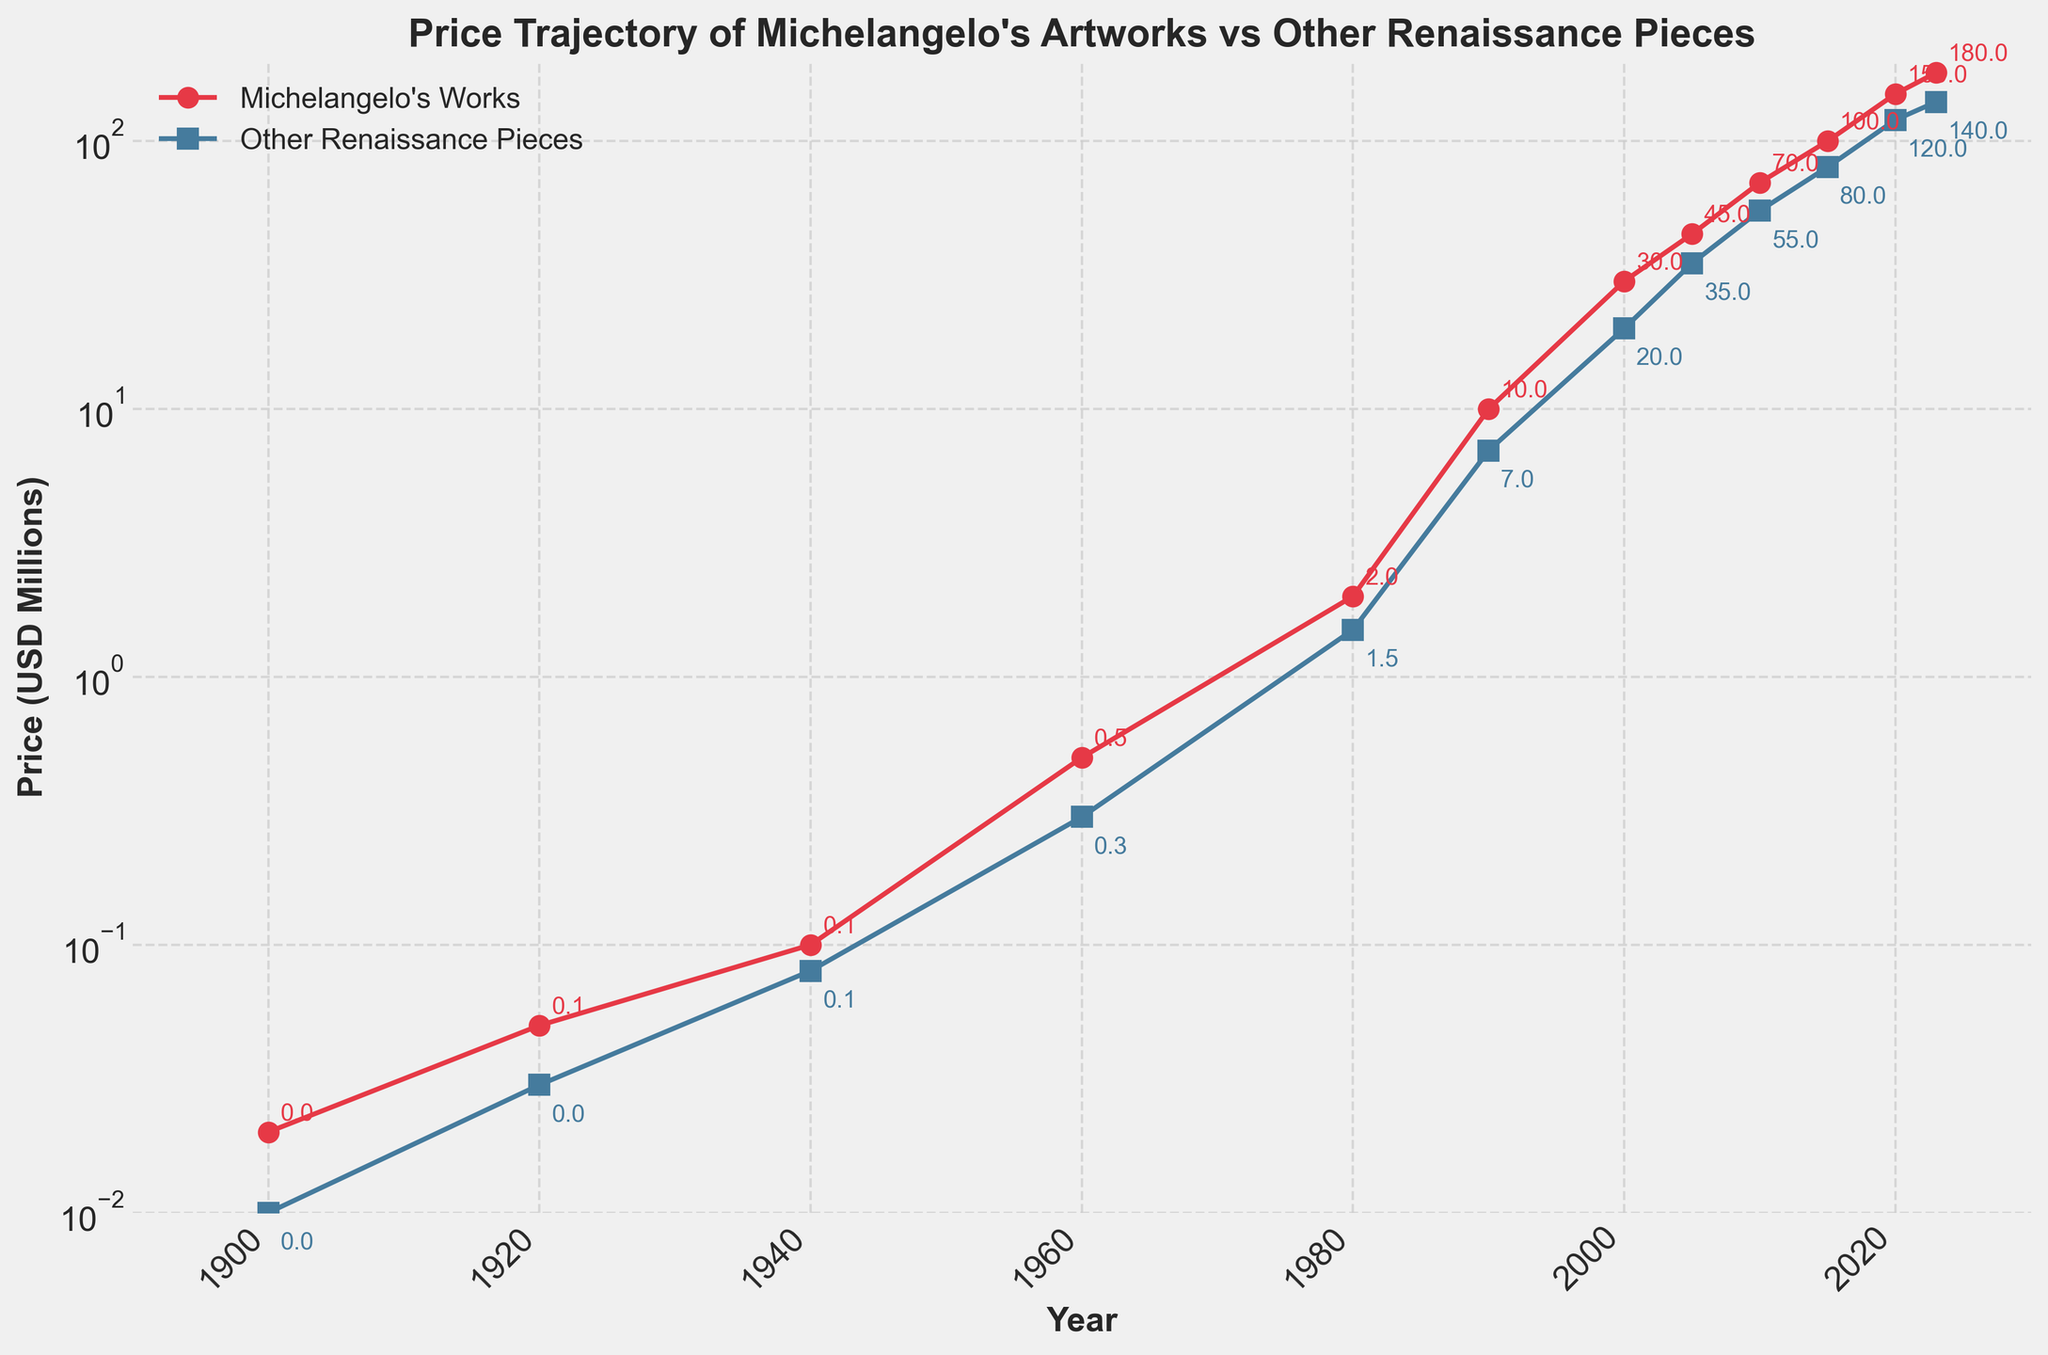what's the average price of Michelangelo's Works in the 20th century (1900-2000)? The 20th century includes the years 1900, 1920, 1940, 1960, 1980, 1990, and 2000. The values for these years are 0.02, 0.05, 0.1, 0.5, 2, 10, and 30. Summing them, we get 0.02 + 0.05 + 0.1 + 0.5 + 2 + 10 + 30 = 42.67. There are 7 values, so the average is 42.67 / 7 = 6.10
Answer: 6.10 Which year saw a larger increase in price for Michelangelo's Works compared to the previous data point, 2000 or 2010? Michelangelo's Works increased from 30 in 2000 to 45 in 2005 (an increase of 15), from 45 in 2005 to 70 in 2010 (an increase of 25). Comparing the increases, 25 is larger than 15.
Answer: 2010 How much more expensive are Michelangelo's Works compared to other Renaissance pieces in 2023? In 2023, Michelangelo's Works are priced at 180 million, and other Renaissance pieces are priced at 140 million. The difference is 180 - 140 = 40 million.
Answer: 40 million In which decades did prices for both Michelangelo's Works and other Renaissance pieces increase significantly? Both Michelangelo's Works and other Renaissance pieces increased significantly from 2000 to 2005, from 2005 to 2010, and from 2010 to 2015 and 2015 to 2020. In these periods, Michelangelo's Works increased by 15, 25, 30, and 50 million, respectively, and other Renaissance pieces increased by 15, 20, 25, and 40 million, respectively.
Answer: 2000-2005, 2005-2010, 2010-2015, 2015-2020 Observing the plot, which color represents Michelangelo's Works and which represents other Renaissance pieces? The plot shows Michelangelo's Works in red and other Renaissance pieces in blue, as indicated by the color of the lines and markers.
Answer: red, blue 